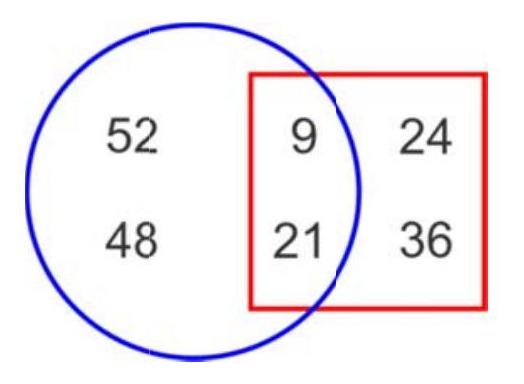Can you tell how many numbers are only inside the square but not in the circle? All numbers inside the square (9, 21, 24, 36) are also inside the circle, so there are no numbers only inside the square and not in the circle. 